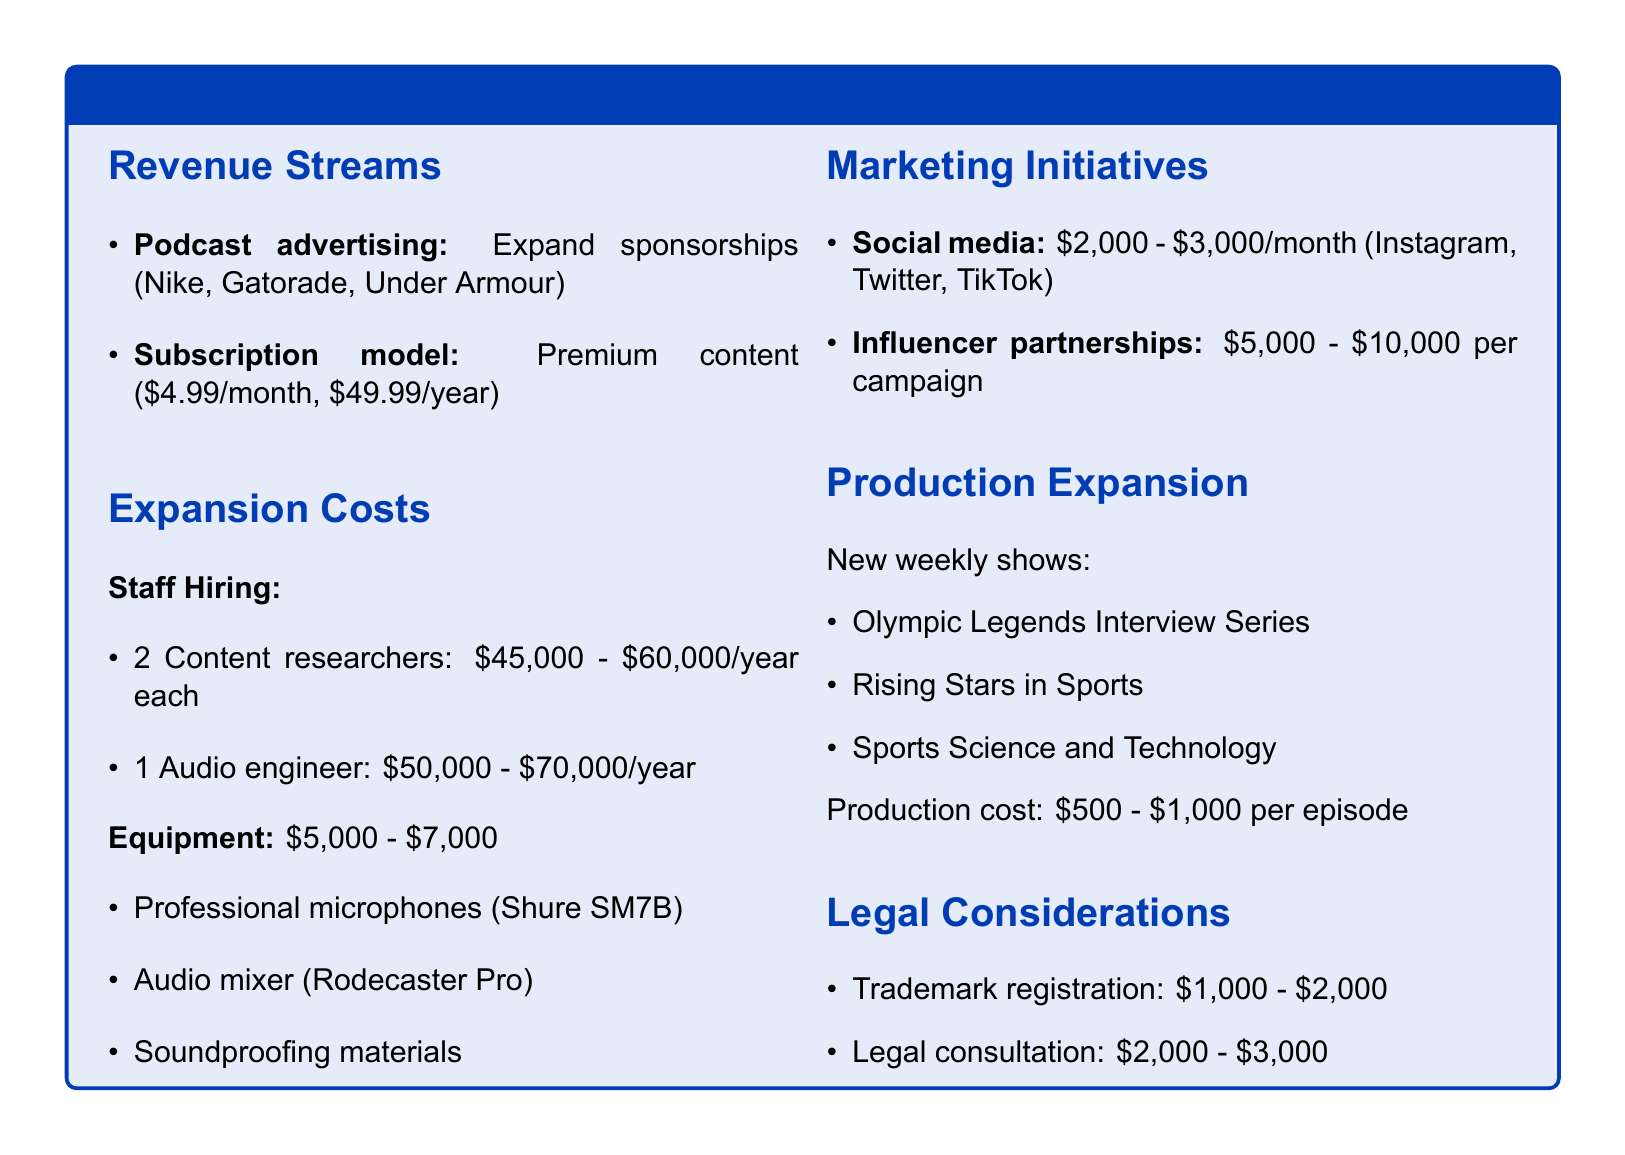What are the podcast advertising sponsors? The document lists specific sponsors under podcast advertising.
Answer: Nike, Gatorade, Under Armour What is the cost range for hiring content researchers? The document specifies the annual salary range for hiring two content researchers.
Answer: 45,000 - 60,000 How much is the estimated production cost per episode? The document provides the production cost figure for each new show episode.
Answer: 500 - 1,000 What type of marketing initiatives are included? The document outlines different marketing strategies under marketing initiatives.
Answer: Social media, Influencer partnerships What is the equipment budget range? The document states the cost range for necessary podcast equipment.
Answer: 5,000 - 7,000 What is the subscription model pricing? The document details the pricing for the subscription model offered.
Answer: 4.99/month, 49.99/year How many new weekly shows are planned? The document lists the new shows that will be produced weekly.
Answer: Three What is the trademark registration cost range? The document provides the financial estimate for trademark registration.
Answer: 1,000 - 2,000 What role will the audio engineer fill? The document identifies the specific staff role related to audio engineering.
Answer: Audio engineer 